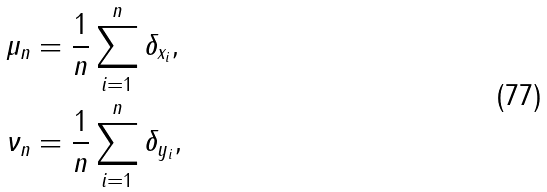Convert formula to latex. <formula><loc_0><loc_0><loc_500><loc_500>\mu _ { n } & = \frac { 1 } { n } \sum _ { i = 1 } ^ { n } \delta _ { x _ { i } } , \\ \nu _ { n } & = \frac { 1 } { n } \sum _ { i = 1 } ^ { n } \delta _ { y _ { i } } ,</formula> 